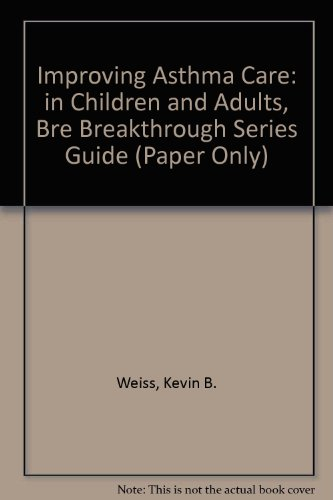Can you tell me more about the author mentioned on the cover? Kevin B. Weiss, the author mentioned on the cover, is known for his work on health care improvement, with a focus on chronic conditions such as asthma. 